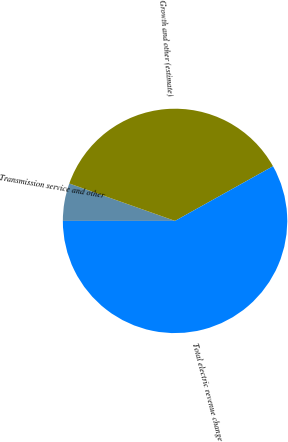<chart> <loc_0><loc_0><loc_500><loc_500><pie_chart><fcel>Transmission service and other<fcel>Growth and other (estimate)<fcel>Total electric revenue change<nl><fcel>5.41%<fcel>36.49%<fcel>58.11%<nl></chart> 